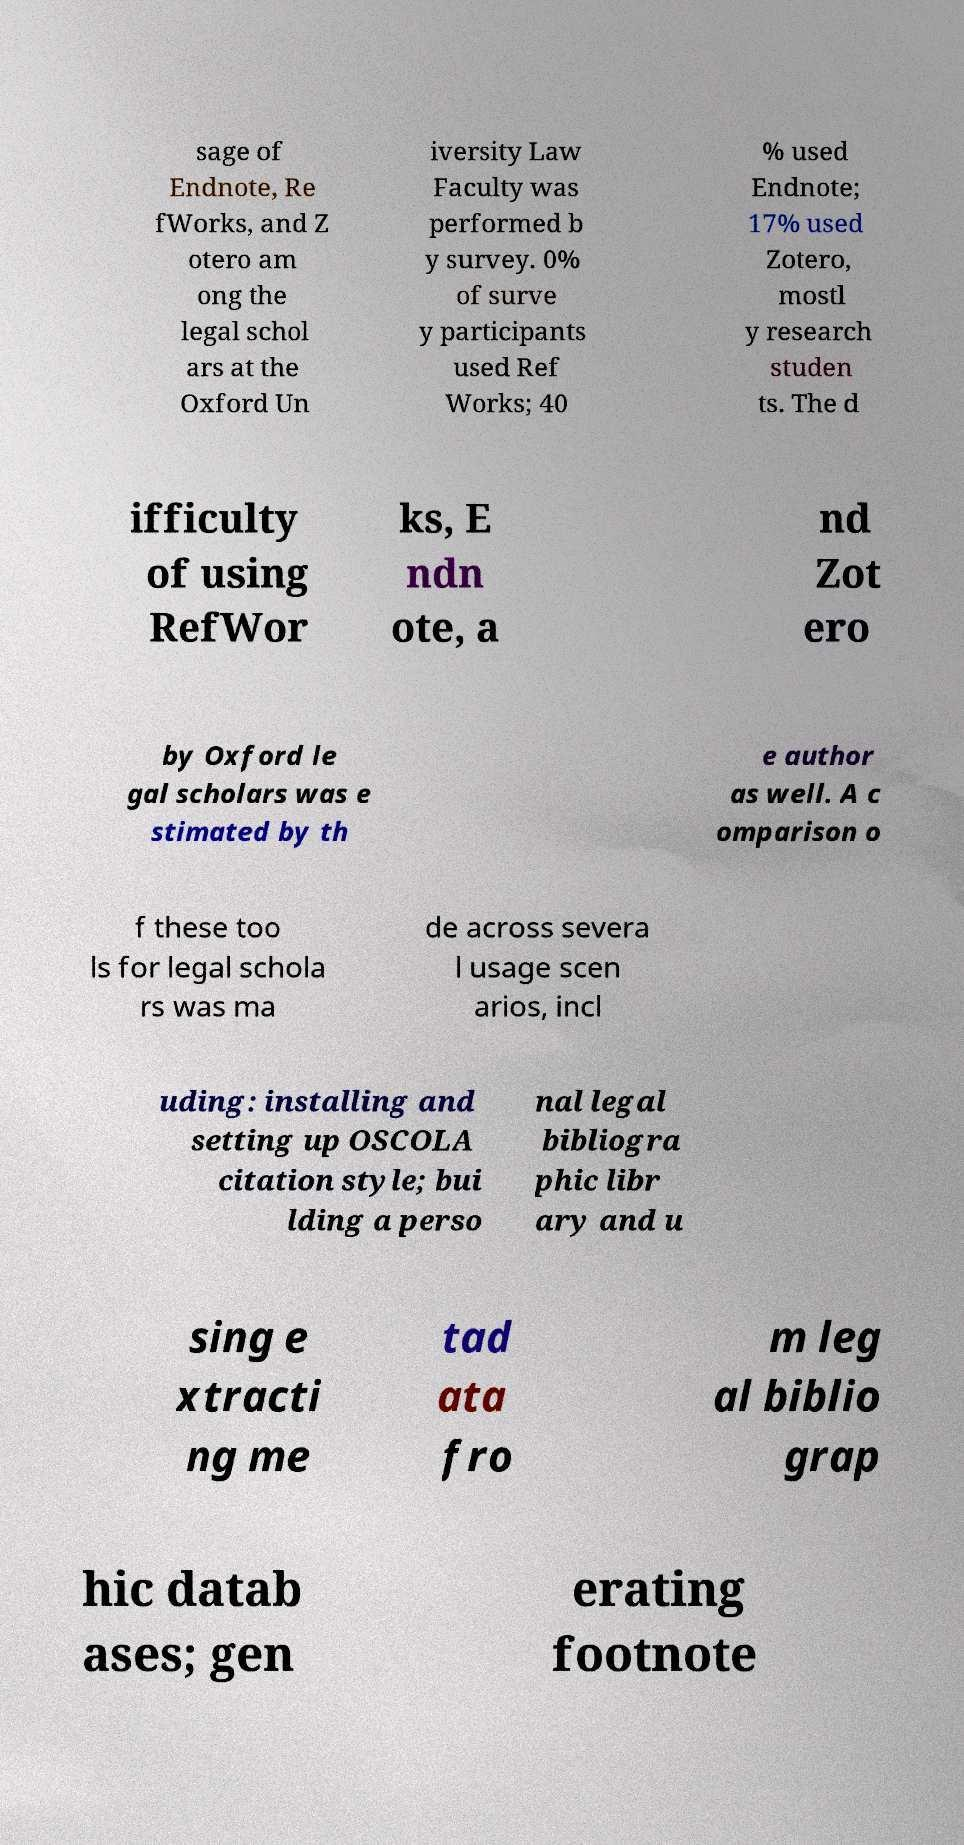For documentation purposes, I need the text within this image transcribed. Could you provide that? sage of Endnote, Re fWorks, and Z otero am ong the legal schol ars at the Oxford Un iversity Law Faculty was performed b y survey. 0% of surve y participants used Ref Works; 40 % used Endnote; 17% used Zotero, mostl y research studen ts. The d ifficulty of using RefWor ks, E ndn ote, a nd Zot ero by Oxford le gal scholars was e stimated by th e author as well. A c omparison o f these too ls for legal schola rs was ma de across severa l usage scen arios, incl uding: installing and setting up OSCOLA citation style; bui lding a perso nal legal bibliogra phic libr ary and u sing e xtracti ng me tad ata fro m leg al biblio grap hic datab ases; gen erating footnote 